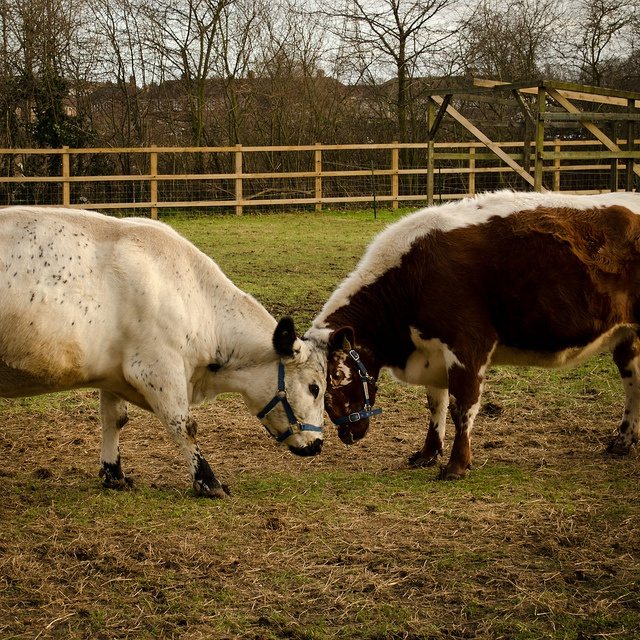Describe the objects in this image and their specific colors. I can see cow in gray, black, maroon, olive, and tan tones and cow in gray, tan, and olive tones in this image. 